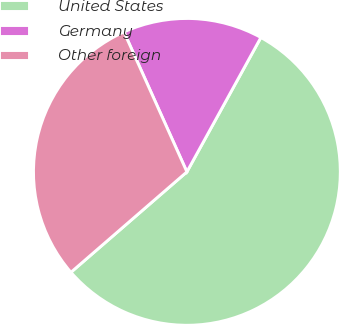Convert chart to OTSL. <chart><loc_0><loc_0><loc_500><loc_500><pie_chart><fcel>United States<fcel>Germany<fcel>Other foreign<nl><fcel>55.63%<fcel>14.74%<fcel>29.63%<nl></chart> 